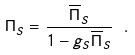Convert formula to latex. <formula><loc_0><loc_0><loc_500><loc_500>\Pi _ { S } = \frac { \overline { \Pi } _ { S } } { 1 - g _ { S } \overline { \Pi } _ { S } } \ .</formula> 